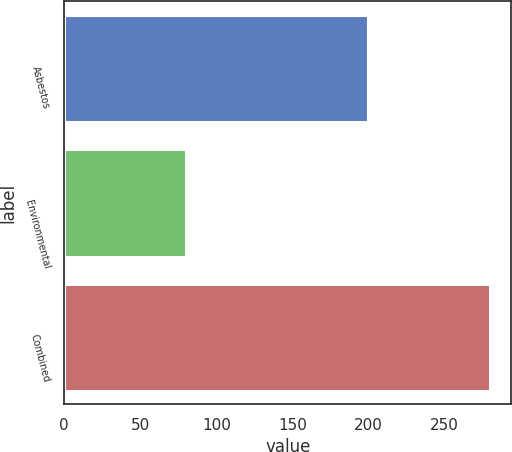Convert chart to OTSL. <chart><loc_0><loc_0><loc_500><loc_500><bar_chart><fcel>Asbestos<fcel>Environmental<fcel>Combined<nl><fcel>200<fcel>80<fcel>280<nl></chart> 